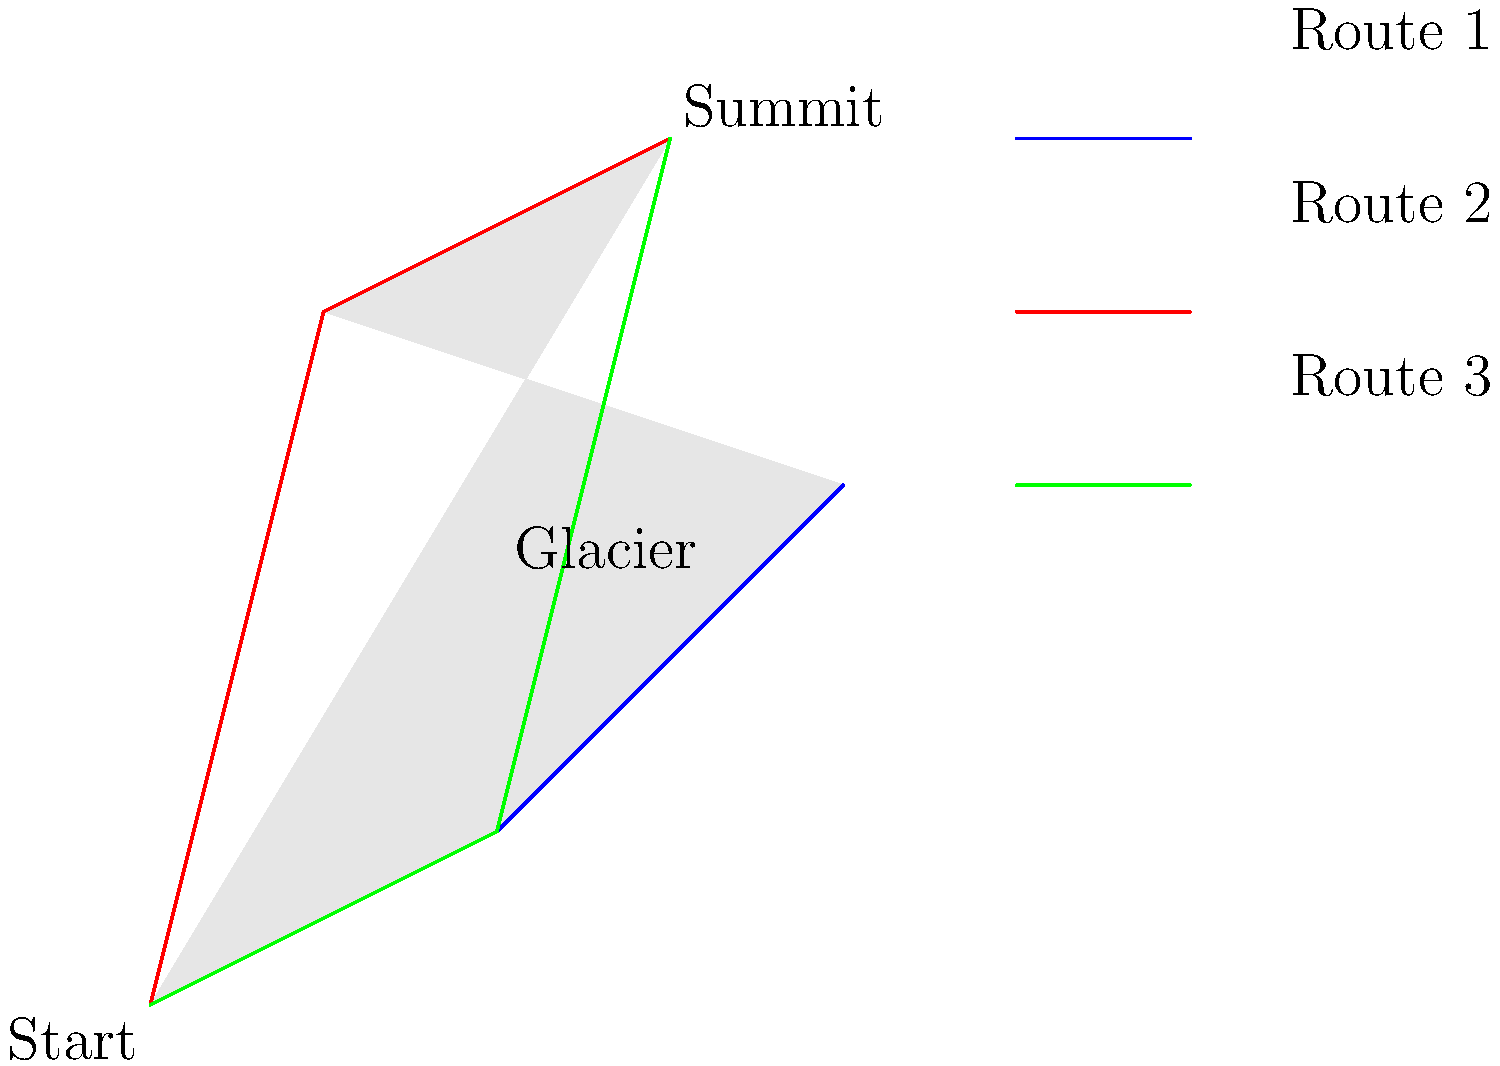Given the satellite imagery of a complex glacial terrain in the Sierra Nevada range, which route to the summit is likely to be the safest and most efficient for an experienced mountaineer, considering factors such as distance, elevation gain, and potential hazards? To determine the safest and most efficient route, we need to analyze each path:

1. Route 1 (Blue):
   - Appears to be the longest route
   - Has a gradual ascent, which could be easier on energy expenditure
   - Crosses the glacier, which poses potential crevasse risks

2. Route 2 (Red):
   - Shortest in terms of horizontal distance
   - Has the steepest ascent, which could be more physically demanding
   - Avoids the glacier, reducing crevasse risks
   - May have increased risk of rockfall due to steepness

3. Route 3 (Green):
   - Moderate length, between Routes 1 and 2
   - Has a balanced ascent profile, neither too steep nor too gradual
   - Partially crosses the glacier, but for a shorter distance than Route 1
   - Provides a good balance between distance and elevation gain

For an experienced mountaineer:
- Route 3 (Green) offers the best balance of safety and efficiency
- It avoids the steepest sections while not being overly long
- The partial glacier crossing can be managed with proper equipment and experience
- The moderate ascent allows for steady progress without excessive energy expenditure

Therefore, Route 3 (Green) is likely to be the safest and most efficient choice for an experienced mountaineer in this terrain.
Answer: Route 3 (Green) 